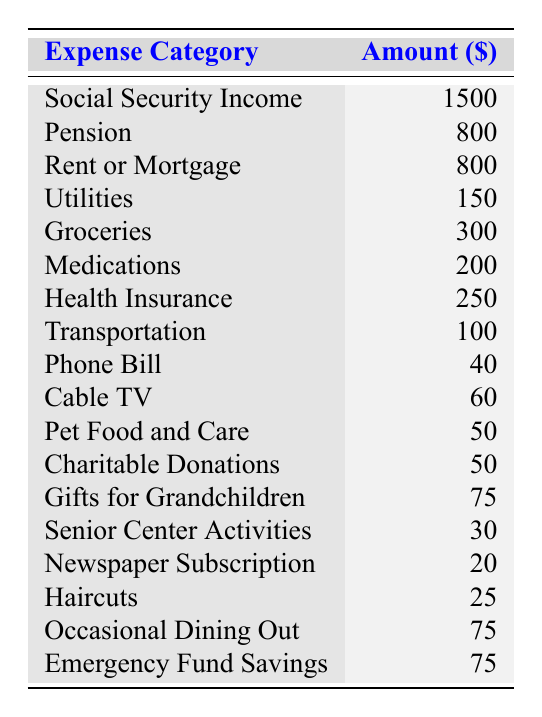What is the total income from Social Security and Pension? To find the total income, we add the amounts from both categories: Social Security Income ($1500) + Pension ($800) = $2300.
Answer: 2300 What is the total amount spent on Health-related expenses (Medications and Health Insurance)? We add the amounts for Medications ($200) and Health Insurance ($250): $200 + $250 = $450.
Answer: 450 How much is allocated for Housing (Rent or Mortgage)? The amount designated for Rent or Mortgage is $800 as shown in the Housing category.
Answer: 800 Is the amount spent on Groceries greater than the amount spent on Transportation? We compare the amounts: Groceries ($300) vs. Transportation ($100). Since $300 is greater than $100, the answer is yes.
Answer: Yes What is the combined cost of Utilities, Phone Bill, and Cable TV? We find the total by adding the amounts: Utilities ($150) + Phone Bill ($40) + Cable TV ($60) = $150 + $40 + $60 = $250.
Answer: 250 How much money is allocated for Charity and Gifts for Grandchildren together? We sum the two amounts: Charitable Donations ($50) + Gifts for Grandchildren ($75) = $125.
Answer: 125 What is the biggest single expense category? By reviewing the amounts, Social Security Income ($1500) is the largest compared to other categories.
Answer: 1500 What is the average monthly spending across all expenses listed? First, we total all expenses: $800 + $150 + $300 + $200 + $250 + $100 + $40 + $60 + $50 + $50 + $75 + $30 + $20 + $25 + $75 + $75 = $2255. Then, we divide by the number of expense categories (16): $2255 / 16 ≈ $140.94.
Answer: Approximately 140.94 Is the total savings for Emergency Fund greater than or less than the Transportation cost? We compare: Emergency Fund Savings ($75) and Transportation ($100). Since $75 is less than $100, the answer is less than.
Answer: Less than What is the total income and how does it compare to total expenses? Total income is $2300 (Social Security + Pension). Total expenses calculated as $2255. So, $2300 (income) exceeds $2255 (expenses) by $45.
Answer: Exceeds by 45 